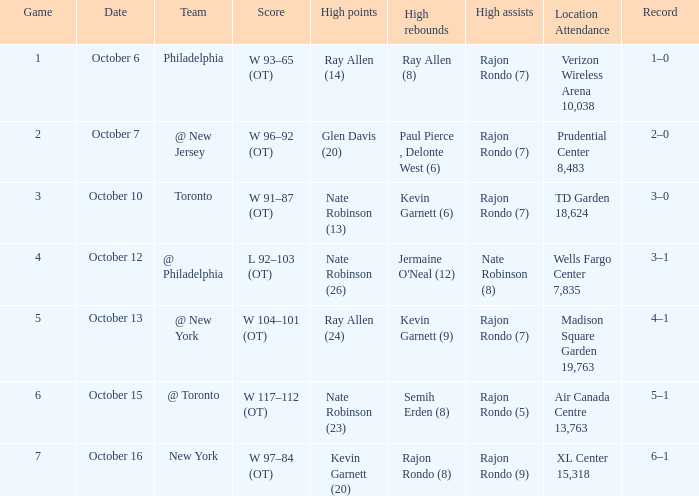Who had the most assists and how many did they have on October 7?  Rajon Rondo (7). 